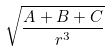Convert formula to latex. <formula><loc_0><loc_0><loc_500><loc_500>\sqrt { \frac { A + B + C } { r ^ { 3 } } }</formula> 